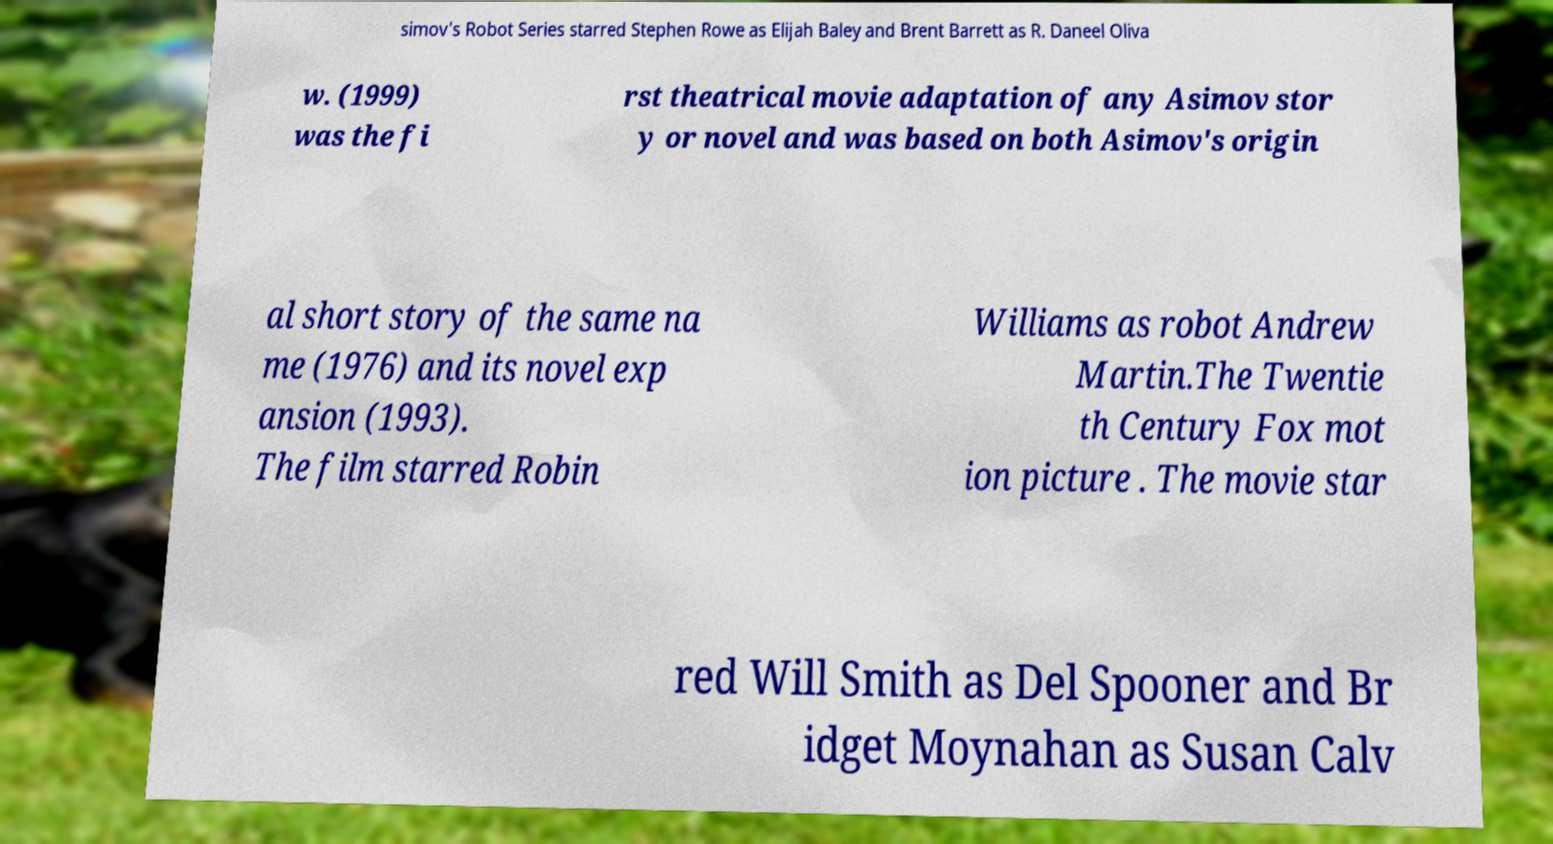Can you read and provide the text displayed in the image?This photo seems to have some interesting text. Can you extract and type it out for me? simov's Robot Series starred Stephen Rowe as Elijah Baley and Brent Barrett as R. Daneel Oliva w. (1999) was the fi rst theatrical movie adaptation of any Asimov stor y or novel and was based on both Asimov's origin al short story of the same na me (1976) and its novel exp ansion (1993). The film starred Robin Williams as robot Andrew Martin.The Twentie th Century Fox mot ion picture . The movie star red Will Smith as Del Spooner and Br idget Moynahan as Susan Calv 